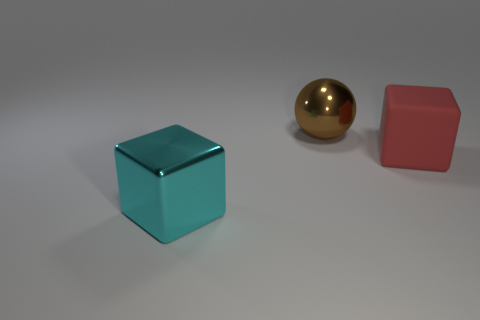Is there any other thing that has the same material as the red block?
Offer a very short reply. No. Are there the same number of large metal balls right of the large red cube and tiny cylinders?
Offer a very short reply. Yes. What number of objects are large shiny objects that are behind the large cyan object or large blue spheres?
Provide a short and direct response. 1. What shape is the big object that is right of the cyan thing and to the left of the large matte thing?
Keep it short and to the point. Sphere. What number of objects are cyan shiny objects that are left of the large sphere or objects right of the large metal block?
Your response must be concise. 3. How many other things are there of the same size as the brown object?
Provide a short and direct response. 2. What number of small objects are shiny spheres or green metal blocks?
Provide a succinct answer. 0. What shape is the large thing that is on the left side of the big brown ball?
Your response must be concise. Cube. What number of big matte things are there?
Provide a succinct answer. 1. Do the cyan thing and the large brown thing have the same material?
Provide a succinct answer. Yes. 